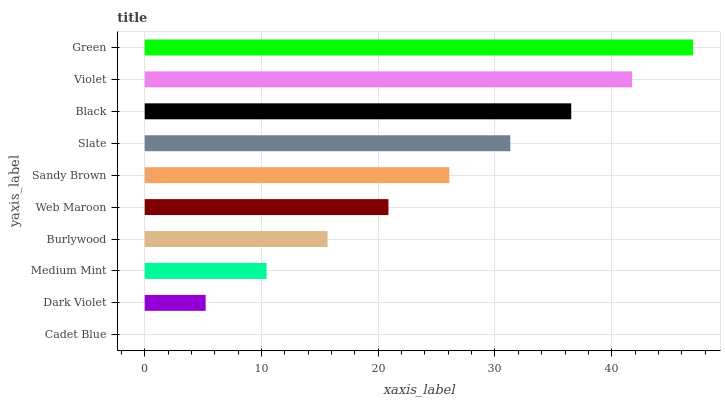Is Cadet Blue the minimum?
Answer yes or no. Yes. Is Green the maximum?
Answer yes or no. Yes. Is Dark Violet the minimum?
Answer yes or no. No. Is Dark Violet the maximum?
Answer yes or no. No. Is Dark Violet greater than Cadet Blue?
Answer yes or no. Yes. Is Cadet Blue less than Dark Violet?
Answer yes or no. Yes. Is Cadet Blue greater than Dark Violet?
Answer yes or no. No. Is Dark Violet less than Cadet Blue?
Answer yes or no. No. Is Sandy Brown the high median?
Answer yes or no. Yes. Is Web Maroon the low median?
Answer yes or no. Yes. Is Green the high median?
Answer yes or no. No. Is Slate the low median?
Answer yes or no. No. 